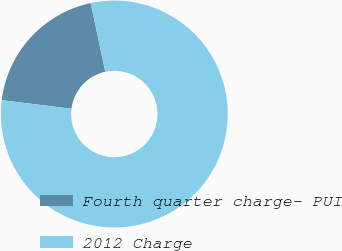<chart> <loc_0><loc_0><loc_500><loc_500><pie_chart><fcel>Fourth quarter charge- PUI<fcel>2012 Charge<nl><fcel>19.71%<fcel>80.29%<nl></chart> 